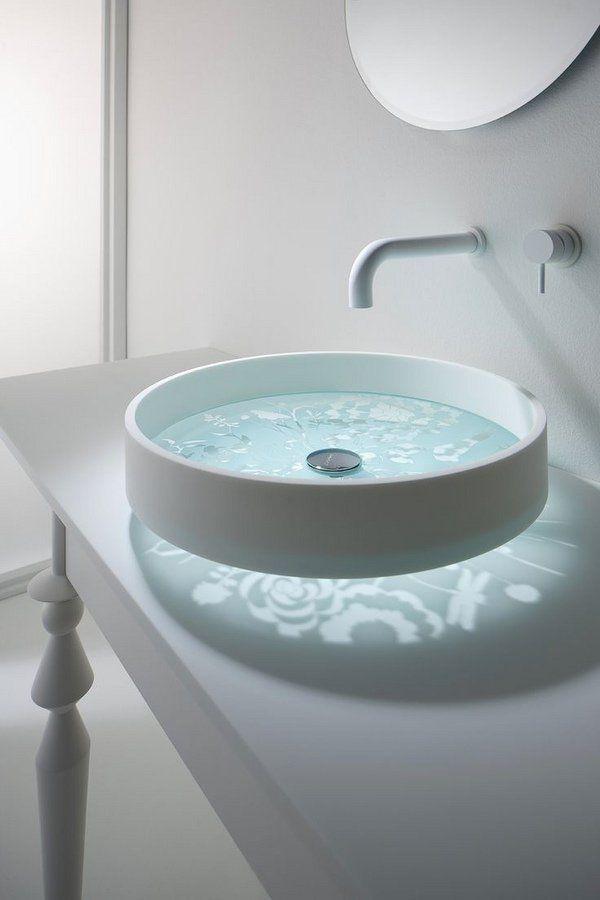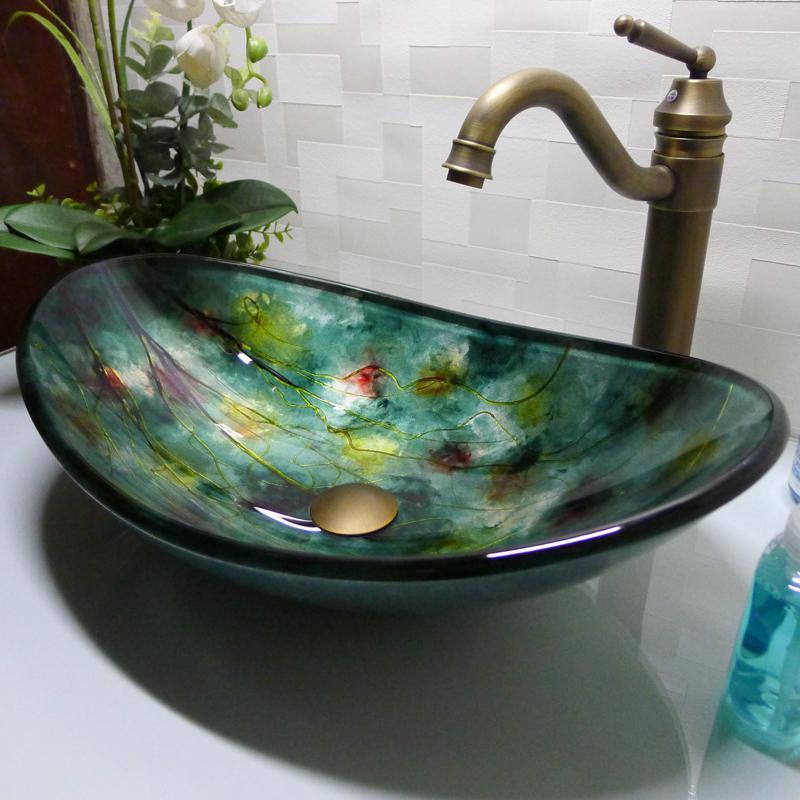The first image is the image on the left, the second image is the image on the right. Evaluate the accuracy of this statement regarding the images: "At least one image contains a transparent wash basin.". Is it true? Answer yes or no. No. 